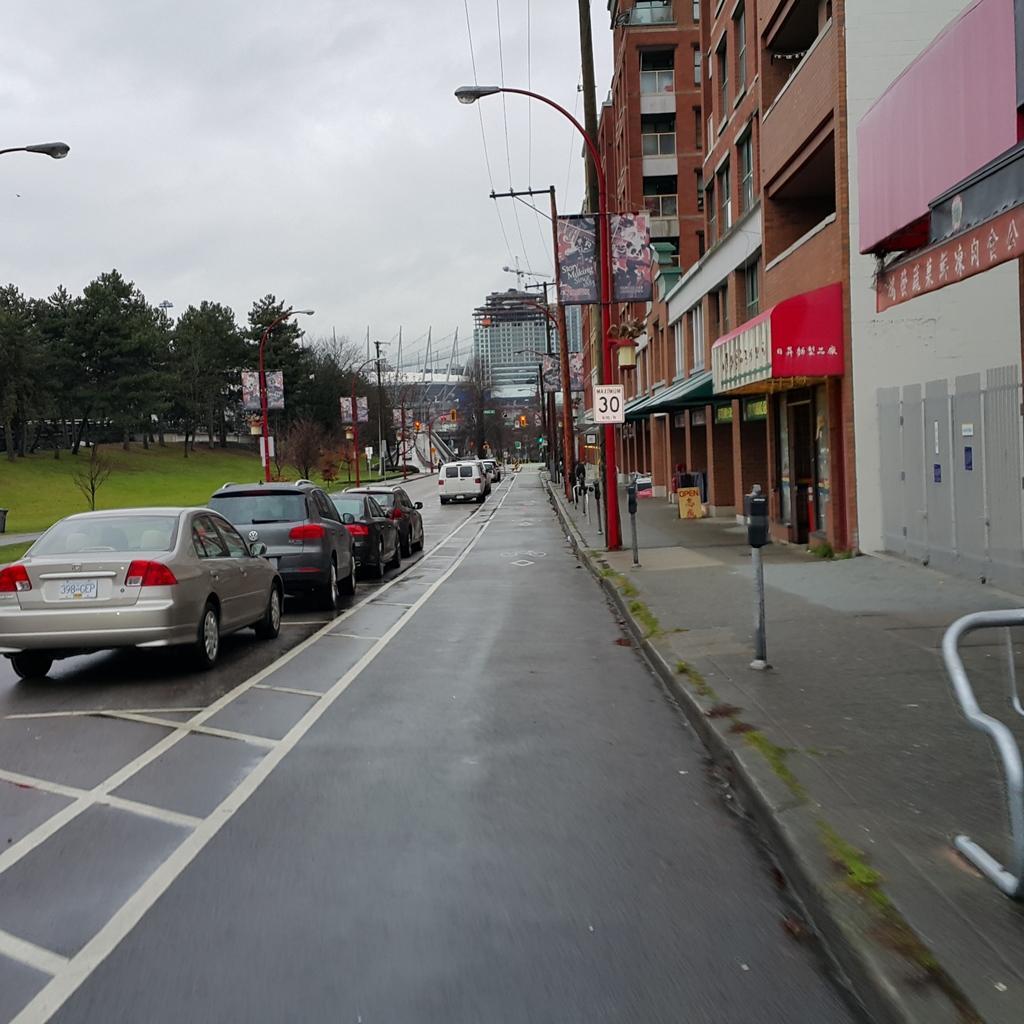Describe this image in one or two sentences. In this image we can see motor vehicles on the road, barrier poles, street poles, street lights, electric poles, electric cables, trees, advertisement boards, buildings and name boards. In the background we can see sky with clouds. 